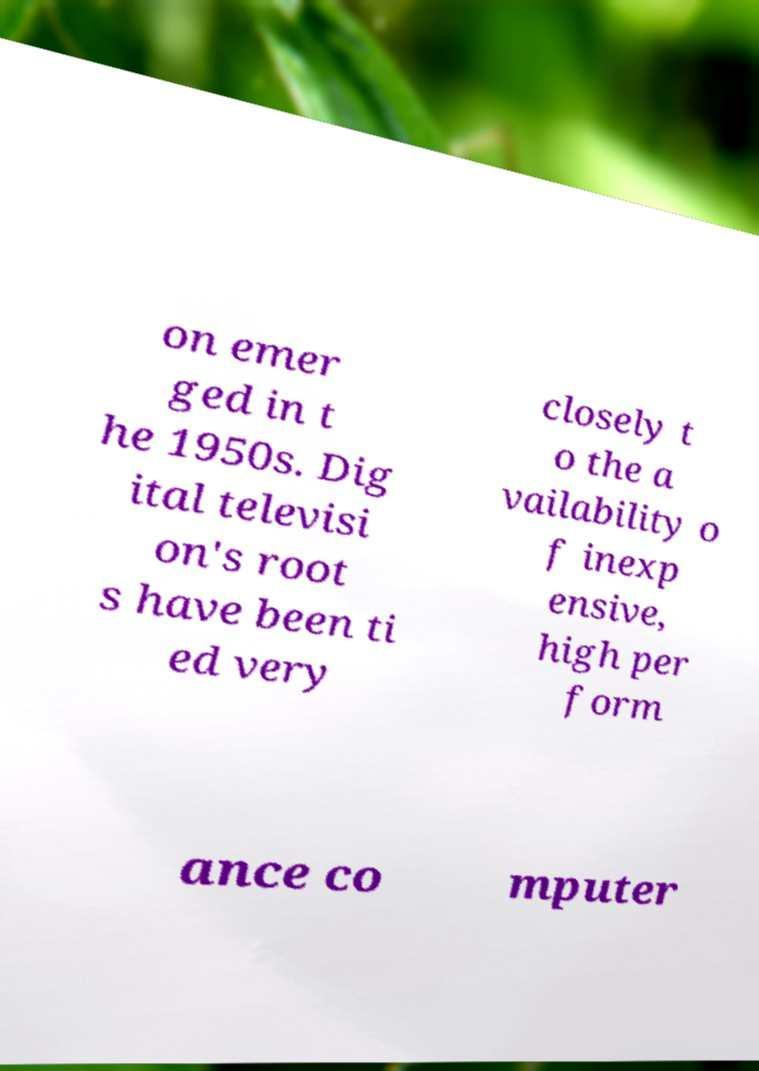Please identify and transcribe the text found in this image. on emer ged in t he 1950s. Dig ital televisi on's root s have been ti ed very closely t o the a vailability o f inexp ensive, high per form ance co mputer 